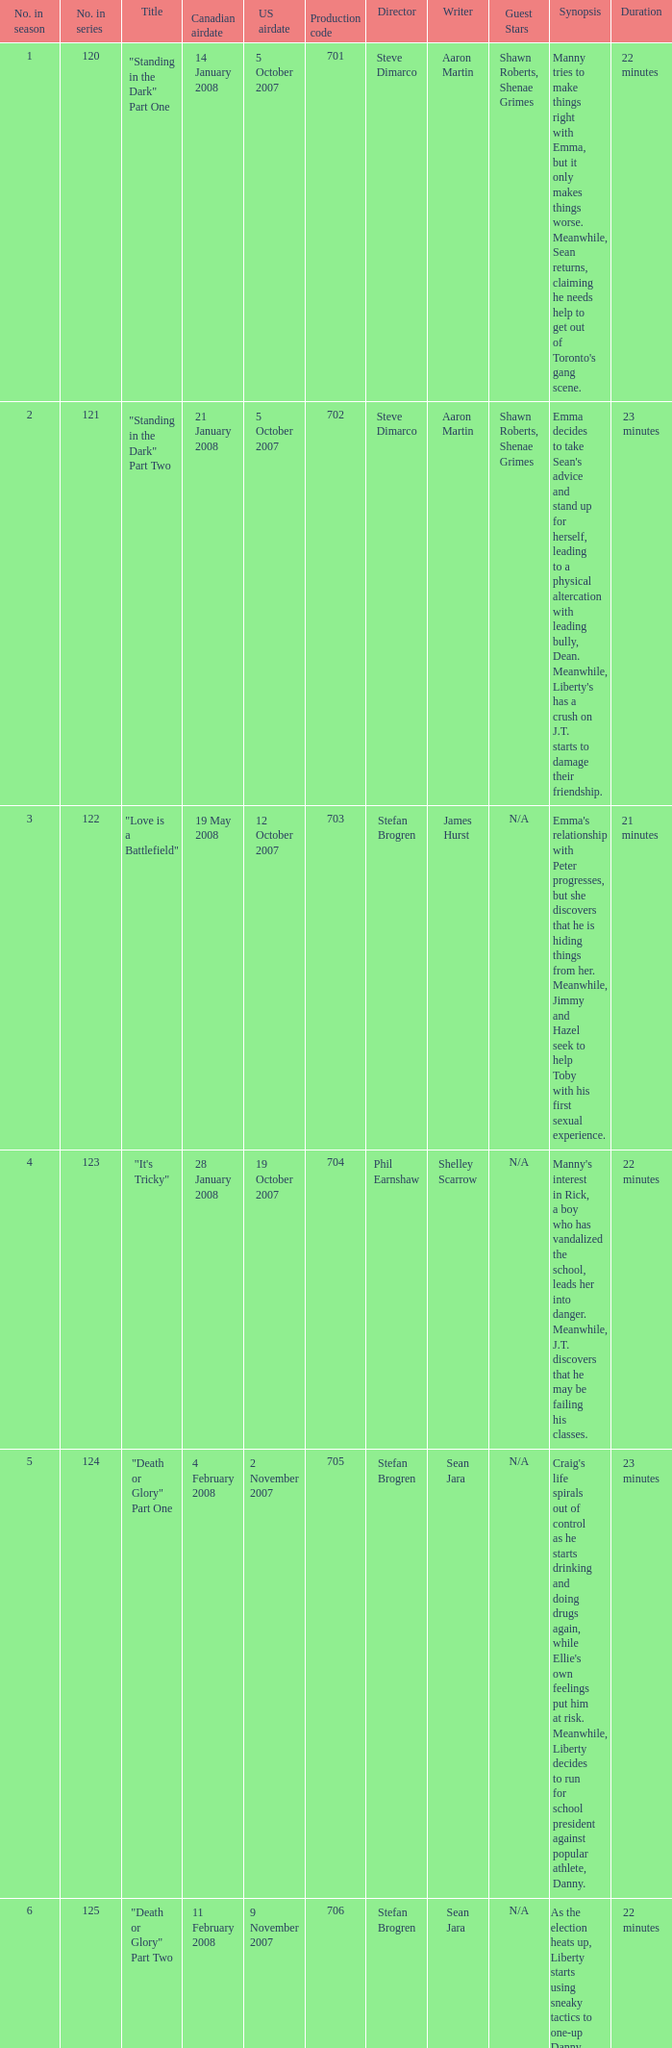The episode titled "don't stop believin'" was what highest number of the season? 22.0. 